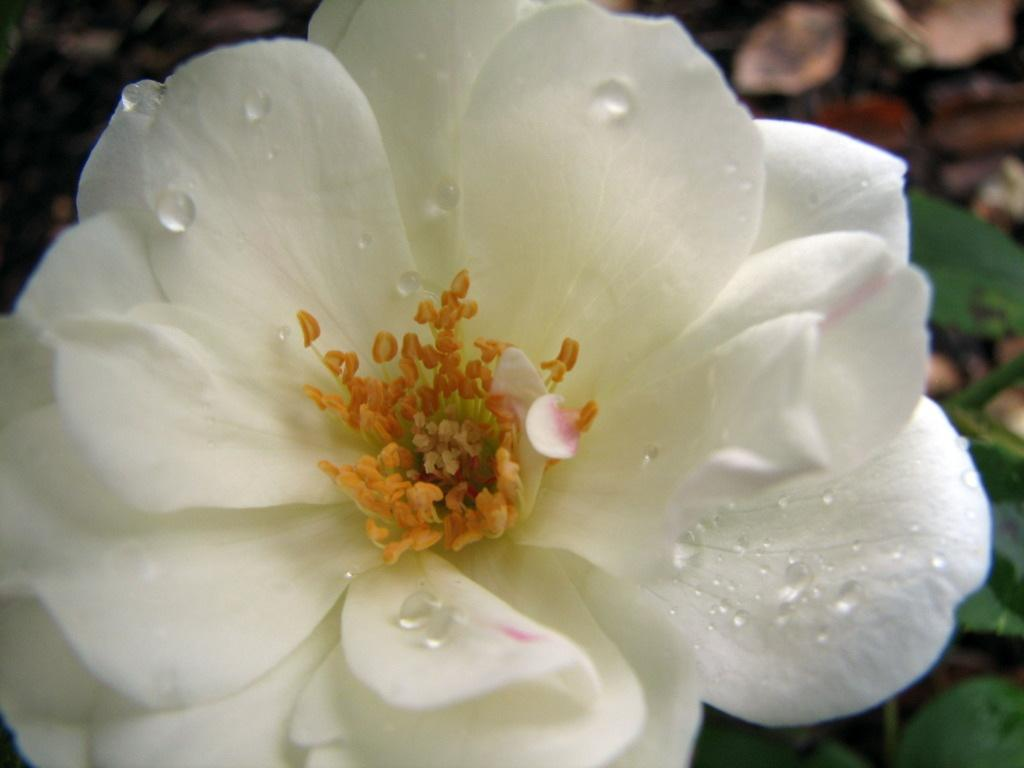What type of flower is present in the image? There is a white-colored flower in the image. What is unique about the appearance of the flower? There are water bubbles on the flower. What type of kettle is visible in the image? There is no kettle present in the image. What type of dolls are interacting with the flower in the image? There are no dolls present in the image. 